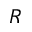Convert formula to latex. <formula><loc_0><loc_0><loc_500><loc_500>R</formula> 